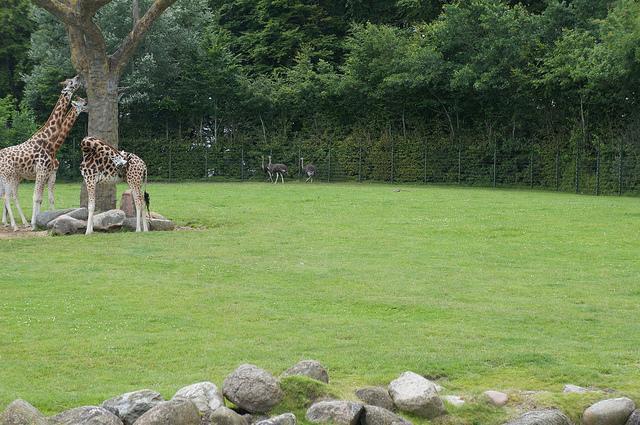The pattern on this animal most closely resembles the pattern on what other animal?
Indicate the correct response by choosing from the four available options to answer the question.
Options: Robin, donkey, cheetah, zebra. Cheetah. 